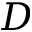Convert formula to latex. <formula><loc_0><loc_0><loc_500><loc_500>D</formula> 